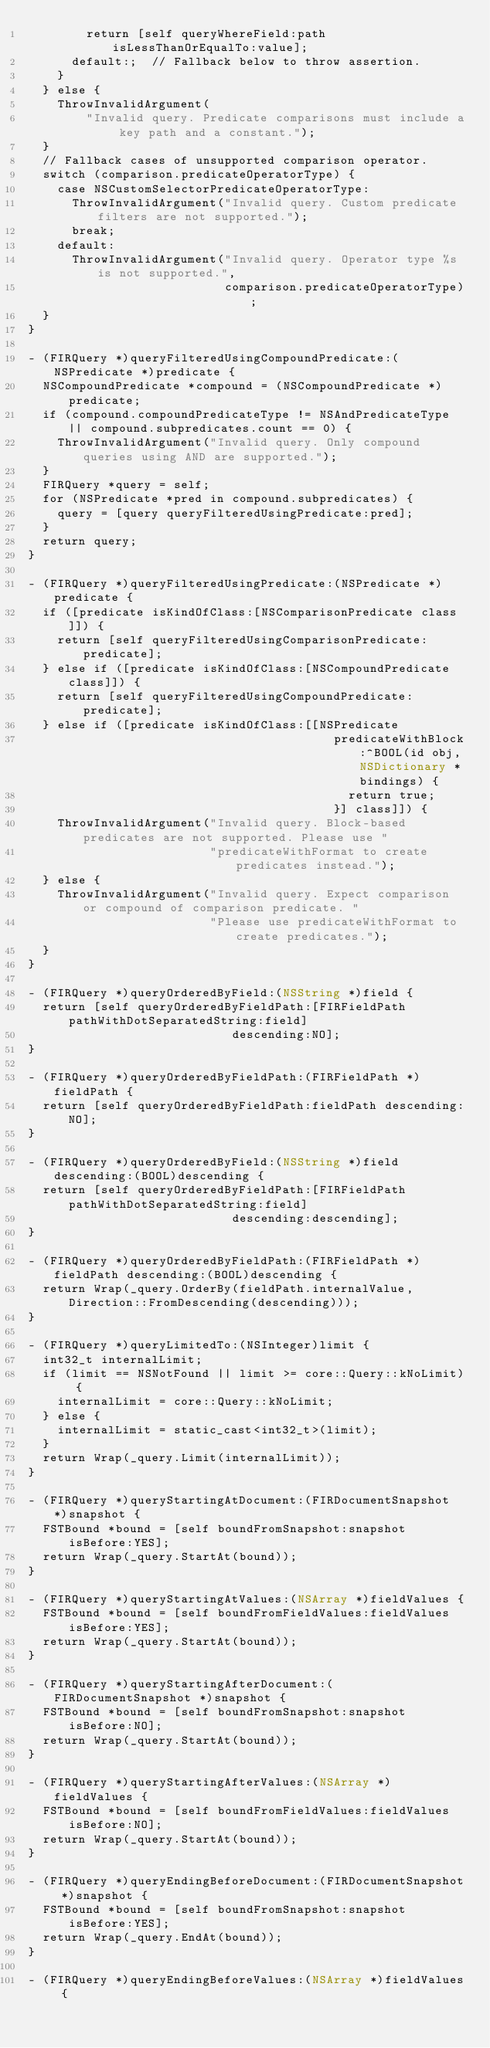Convert code to text. <code><loc_0><loc_0><loc_500><loc_500><_ObjectiveC_>        return [self queryWhereField:path isLessThanOrEqualTo:value];
      default:;  // Fallback below to throw assertion.
    }
  } else {
    ThrowInvalidArgument(
        "Invalid query. Predicate comparisons must include a key path and a constant.");
  }
  // Fallback cases of unsupported comparison operator.
  switch (comparison.predicateOperatorType) {
    case NSCustomSelectorPredicateOperatorType:
      ThrowInvalidArgument("Invalid query. Custom predicate filters are not supported.");
      break;
    default:
      ThrowInvalidArgument("Invalid query. Operator type %s is not supported.",
                           comparison.predicateOperatorType);
  }
}

- (FIRQuery *)queryFilteredUsingCompoundPredicate:(NSPredicate *)predicate {
  NSCompoundPredicate *compound = (NSCompoundPredicate *)predicate;
  if (compound.compoundPredicateType != NSAndPredicateType || compound.subpredicates.count == 0) {
    ThrowInvalidArgument("Invalid query. Only compound queries using AND are supported.");
  }
  FIRQuery *query = self;
  for (NSPredicate *pred in compound.subpredicates) {
    query = [query queryFilteredUsingPredicate:pred];
  }
  return query;
}

- (FIRQuery *)queryFilteredUsingPredicate:(NSPredicate *)predicate {
  if ([predicate isKindOfClass:[NSComparisonPredicate class]]) {
    return [self queryFilteredUsingComparisonPredicate:predicate];
  } else if ([predicate isKindOfClass:[NSCompoundPredicate class]]) {
    return [self queryFilteredUsingCompoundPredicate:predicate];
  } else if ([predicate isKindOfClass:[[NSPredicate
                                          predicateWithBlock:^BOOL(id obj, NSDictionary *bindings) {
                                            return true;
                                          }] class]]) {
    ThrowInvalidArgument("Invalid query. Block-based predicates are not supported. Please use "
                         "predicateWithFormat to create predicates instead.");
  } else {
    ThrowInvalidArgument("Invalid query. Expect comparison or compound of comparison predicate. "
                         "Please use predicateWithFormat to create predicates.");
  }
}

- (FIRQuery *)queryOrderedByField:(NSString *)field {
  return [self queryOrderedByFieldPath:[FIRFieldPath pathWithDotSeparatedString:field]
                            descending:NO];
}

- (FIRQuery *)queryOrderedByFieldPath:(FIRFieldPath *)fieldPath {
  return [self queryOrderedByFieldPath:fieldPath descending:NO];
}

- (FIRQuery *)queryOrderedByField:(NSString *)field descending:(BOOL)descending {
  return [self queryOrderedByFieldPath:[FIRFieldPath pathWithDotSeparatedString:field]
                            descending:descending];
}

- (FIRQuery *)queryOrderedByFieldPath:(FIRFieldPath *)fieldPath descending:(BOOL)descending {
  return Wrap(_query.OrderBy(fieldPath.internalValue, Direction::FromDescending(descending)));
}

- (FIRQuery *)queryLimitedTo:(NSInteger)limit {
  int32_t internalLimit;
  if (limit == NSNotFound || limit >= core::Query::kNoLimit) {
    internalLimit = core::Query::kNoLimit;
  } else {
    internalLimit = static_cast<int32_t>(limit);
  }
  return Wrap(_query.Limit(internalLimit));
}

- (FIRQuery *)queryStartingAtDocument:(FIRDocumentSnapshot *)snapshot {
  FSTBound *bound = [self boundFromSnapshot:snapshot isBefore:YES];
  return Wrap(_query.StartAt(bound));
}

- (FIRQuery *)queryStartingAtValues:(NSArray *)fieldValues {
  FSTBound *bound = [self boundFromFieldValues:fieldValues isBefore:YES];
  return Wrap(_query.StartAt(bound));
}

- (FIRQuery *)queryStartingAfterDocument:(FIRDocumentSnapshot *)snapshot {
  FSTBound *bound = [self boundFromSnapshot:snapshot isBefore:NO];
  return Wrap(_query.StartAt(bound));
}

- (FIRQuery *)queryStartingAfterValues:(NSArray *)fieldValues {
  FSTBound *bound = [self boundFromFieldValues:fieldValues isBefore:NO];
  return Wrap(_query.StartAt(bound));
}

- (FIRQuery *)queryEndingBeforeDocument:(FIRDocumentSnapshot *)snapshot {
  FSTBound *bound = [self boundFromSnapshot:snapshot isBefore:YES];
  return Wrap(_query.EndAt(bound));
}

- (FIRQuery *)queryEndingBeforeValues:(NSArray *)fieldValues {</code> 